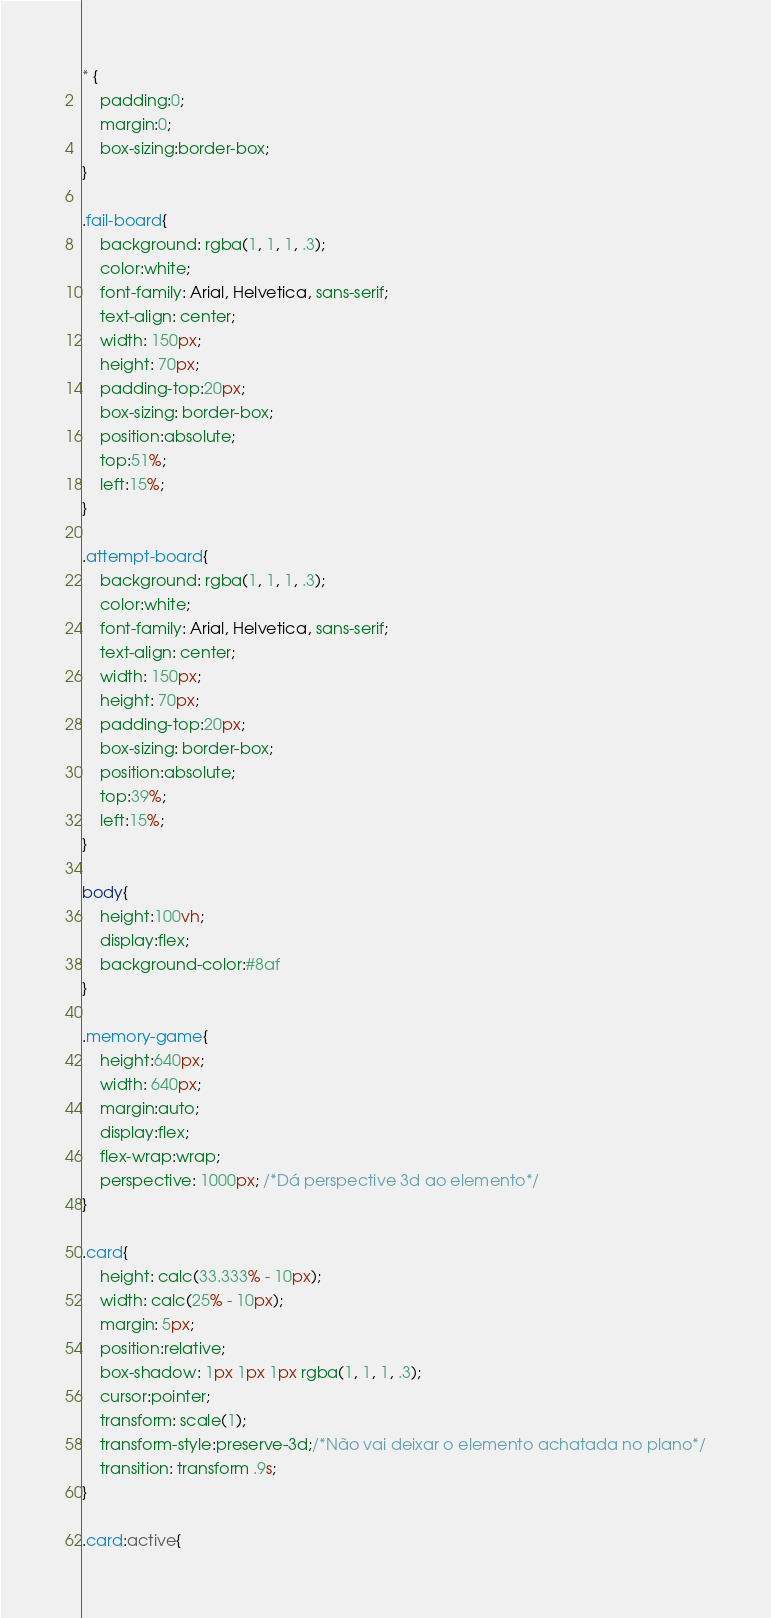Convert code to text. <code><loc_0><loc_0><loc_500><loc_500><_CSS_>* {
    padding:0;
    margin:0;
    box-sizing:border-box;
}

.fail-board{
    background: rgba(1, 1, 1, .3);
    color:white;
    font-family: Arial, Helvetica, sans-serif;
    text-align: center;
    width: 150px;
    height: 70px;
    padding-top:20px;
    box-sizing: border-box;
    position:absolute;
    top:51%;
    left:15%;
}

.attempt-board{
    background: rgba(1, 1, 1, .3);
    color:white;
    font-family: Arial, Helvetica, sans-serif;
    text-align: center;
    width: 150px;
    height: 70px;
    padding-top:20px;
    box-sizing: border-box;
    position:absolute;
    top:39%;
    left:15%;
}

body{
    height:100vh;
    display:flex;
    background-color:#8af
}

.memory-game{
    height:640px;
    width: 640px;
    margin:auto;
    display:flex;
    flex-wrap:wrap;
    perspective: 1000px; /*Dá perspective 3d ao elemento*/
}

.card{
    height: calc(33.333% - 10px);
    width: calc(25% - 10px);
    margin: 5px;
    position:relative;
    box-shadow: 1px 1px 1px rgba(1, 1, 1, .3);
    cursor:pointer;
    transform: scale(1);
    transform-style:preserve-3d;/*Não vai deixar o elemento achatada no plano*/
    transition: transform .9s;
}

.card:active{</code> 